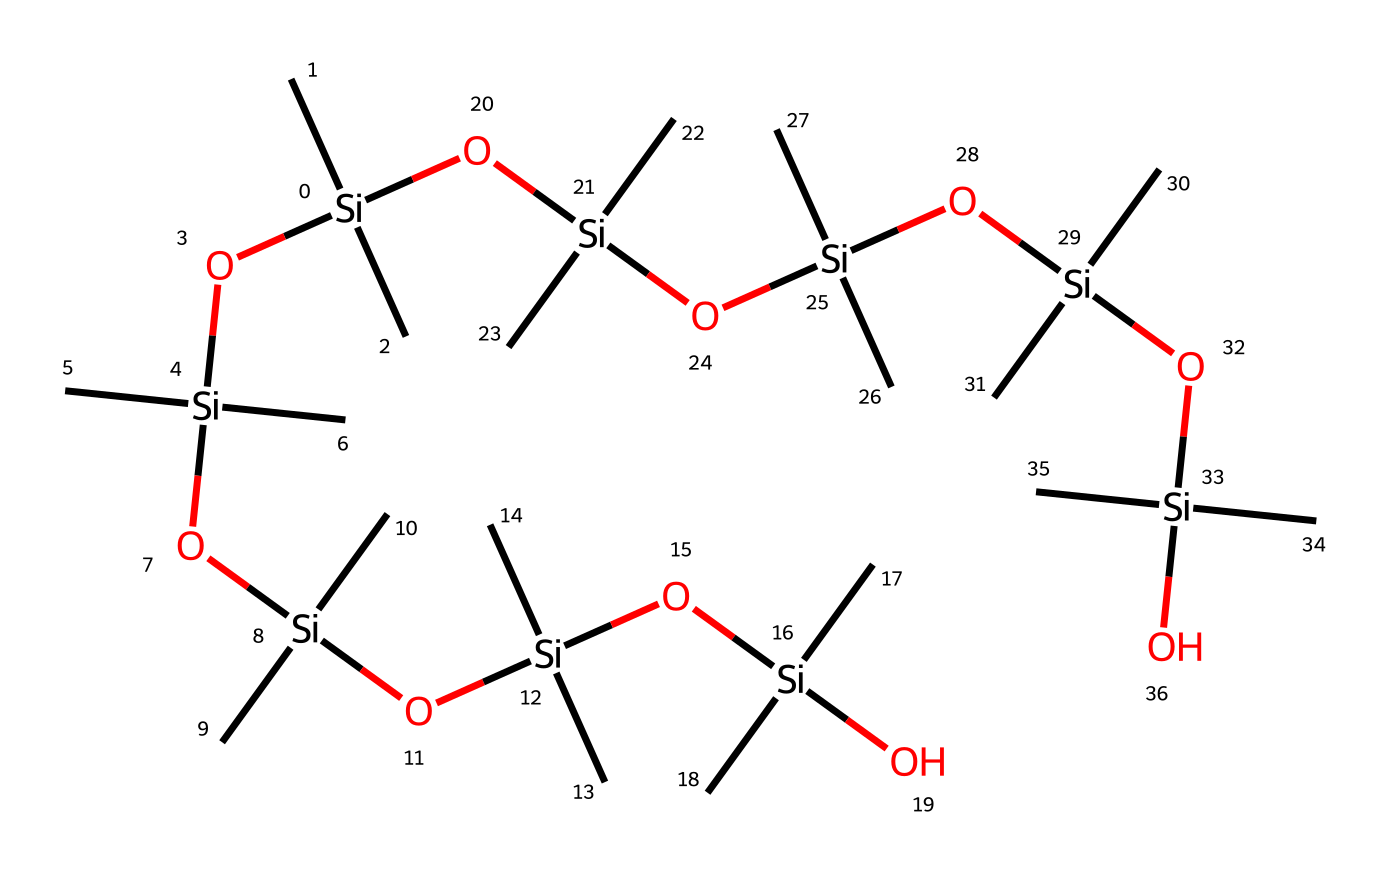What is the central atom in this silicone-based lubricant? The central atom is silicon (Si), which is the primary element that forms the backbone of silicone compounds. In the structure provided, the repeating unit consists of silicon atoms connected through oxygen linkages.
Answer: silicon How many silicon atoms are present in this structure? By examining the SMILES representation, each "[Si]" denotes a silicon atom. There are several occurrences of "[Si]", totaling 10 silicon atoms connected through oxygen linkages and additional carbon groups.
Answer: 10 What type of bonds are primarily found in this silicone-based lubricant? The predominant bonds in this structure are Si-O bonds (silicon-oxygen bonds), which are characteristic of silicone compounds. The presence of carbon groups attached to silicon indicates some C-Si bonds as well, but Si-O is the most significant in the context of lubricants.
Answer: Si-O What functional groups are observed in this chemical structure? The functional groups present are hydroxyl (due to the -OH groups bonded to silicon) and siloxane (Si-O-Si linkages). These functional groups contribute to the lubricant properties such as viscosity and temperature stability.
Answer: hydroxyl and siloxane What is the primary chemical property of silicone-based lubricants? Silicone-based lubricants are known for their excellent stability under a wide range of temperatures and their water resistance. This property results from their silicon-oxygen backbone, making them useful in household appliances.
Answer: stability Why are silicone-based lubricants preferred for household appliances? Silicone-based lubricants provide a non-toxic, stable, and long-lasting solution that does not attract dirt and debris, which is essential for maintaining the efficiency of household appliances. The chemical structure lends to low friction properties as well.
Answer: non-toxic and stable 